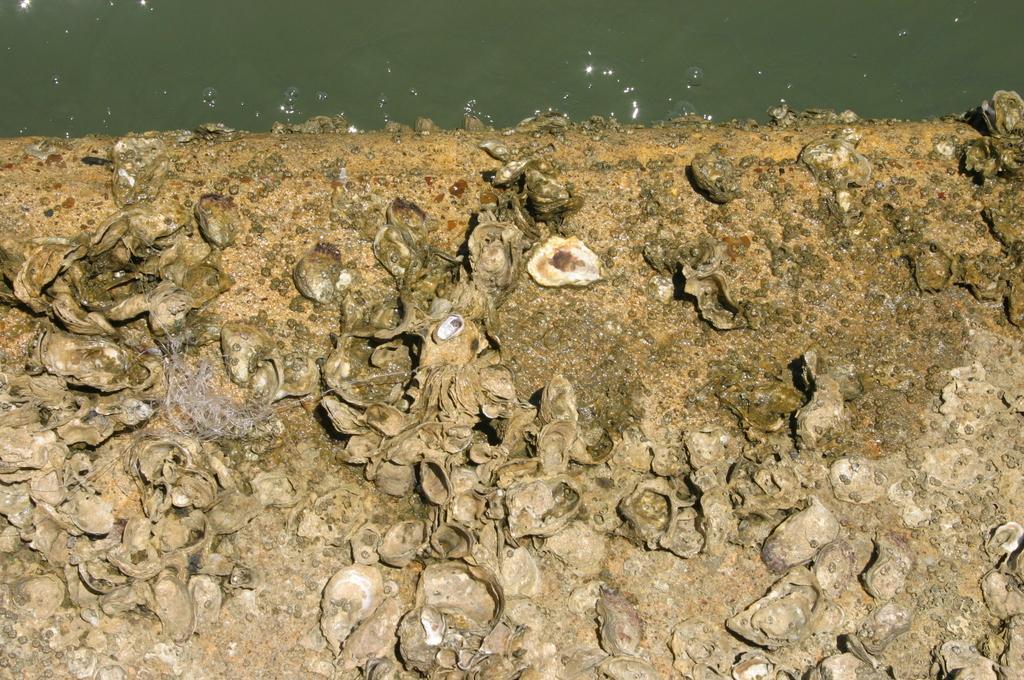Could you give a brief overview of what you see in this image? This image consists of shells on the ground. At the top, we can see water. 